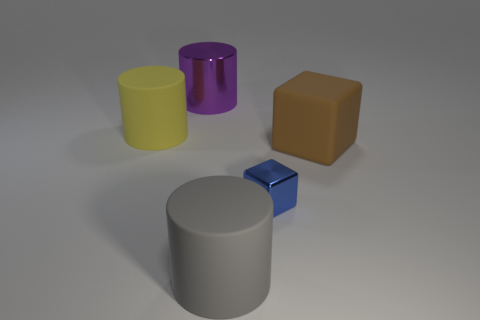Add 3 metallic balls. How many objects exist? 8 Subtract all big yellow matte cylinders. How many cylinders are left? 2 Subtract all yellow cylinders. How many cylinders are left? 2 Subtract 3 cylinders. How many cylinders are left? 0 Add 2 large gray objects. How many large gray objects are left? 3 Add 2 small blue metal objects. How many small blue metal objects exist? 3 Subtract 0 cyan blocks. How many objects are left? 5 Subtract all cubes. How many objects are left? 3 Subtract all red cubes. Subtract all red cylinders. How many cubes are left? 2 Subtract all matte objects. Subtract all big green metal cubes. How many objects are left? 2 